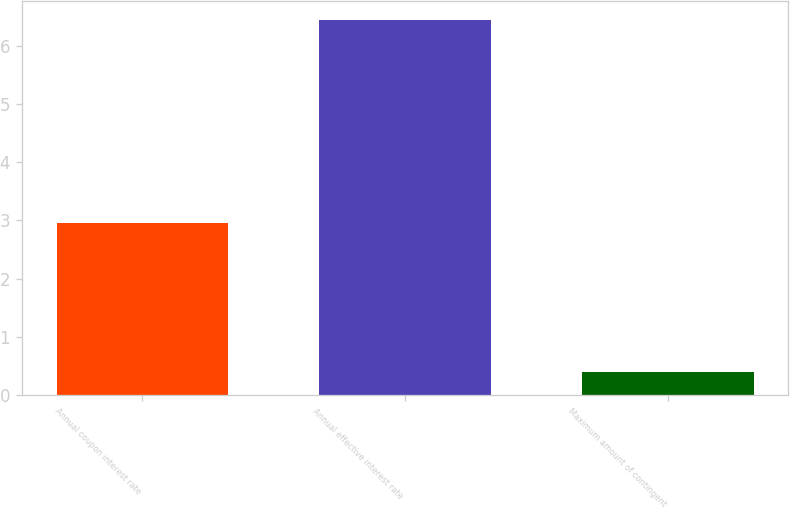Convert chart. <chart><loc_0><loc_0><loc_500><loc_500><bar_chart><fcel>Annual coupon interest rate<fcel>Annual effective interest rate<fcel>Maximum amount of contingent<nl><fcel>2.95<fcel>6.45<fcel>0.4<nl></chart> 